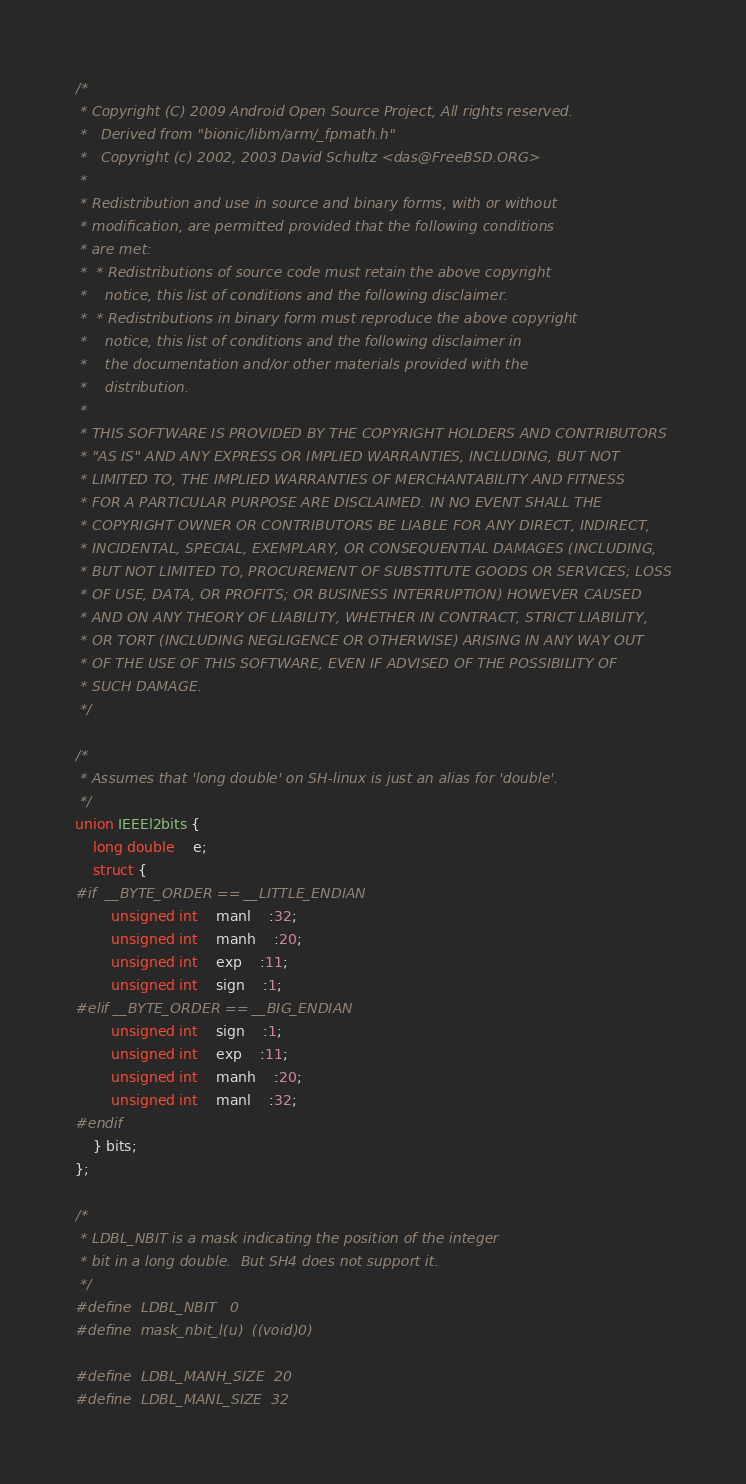Convert code to text. <code><loc_0><loc_0><loc_500><loc_500><_C_>/*
 * Copyright (C) 2009 Android Open Source Project, All rights reserved.
 *   Derived from "bionic/libm/arm/_fpmath.h"
 *   Copyright (c) 2002, 2003 David Schultz <das@FreeBSD.ORG>
 *
 * Redistribution and use in source and binary forms, with or without
 * modification, are permitted provided that the following conditions
 * are met:
 *  * Redistributions of source code must retain the above copyright
 *    notice, this list of conditions and the following disclaimer.
 *  * Redistributions in binary form must reproduce the above copyright
 *    notice, this list of conditions and the following disclaimer in
 *    the documentation and/or other materials provided with the
 *    distribution.
 *
 * THIS SOFTWARE IS PROVIDED BY THE COPYRIGHT HOLDERS AND CONTRIBUTORS
 * "AS IS" AND ANY EXPRESS OR IMPLIED WARRANTIES, INCLUDING, BUT NOT
 * LIMITED TO, THE IMPLIED WARRANTIES OF MERCHANTABILITY AND FITNESS
 * FOR A PARTICULAR PURPOSE ARE DISCLAIMED. IN NO EVENT SHALL THE
 * COPYRIGHT OWNER OR CONTRIBUTORS BE LIABLE FOR ANY DIRECT, INDIRECT,
 * INCIDENTAL, SPECIAL, EXEMPLARY, OR CONSEQUENTIAL DAMAGES (INCLUDING,
 * BUT NOT LIMITED TO, PROCUREMENT OF SUBSTITUTE GOODS OR SERVICES; LOSS
 * OF USE, DATA, OR PROFITS; OR BUSINESS INTERRUPTION) HOWEVER CAUSED
 * AND ON ANY THEORY OF LIABILITY, WHETHER IN CONTRACT, STRICT LIABILITY,
 * OR TORT (INCLUDING NEGLIGENCE OR OTHERWISE) ARISING IN ANY WAY OUT
 * OF THE USE OF THIS SOFTWARE, EVEN IF ADVISED OF THE POSSIBILITY OF
 * SUCH DAMAGE.
 */

/*
 * Assumes that 'long double' on SH-linux is just an alias for 'double'.
 */
union IEEEl2bits {
	long double	e;
	struct {
#if  __BYTE_ORDER == __LITTLE_ENDIAN
		unsigned int	manl	:32;
		unsigned int	manh	:20;
		unsigned int	exp	:11;
		unsigned int	sign	:1;
#elif __BYTE_ORDER == __BIG_ENDIAN
		unsigned int	sign	:1;
		unsigned int	exp	:11;
		unsigned int	manh	:20;
		unsigned int	manl	:32;
#endif
	} bits;
};

/*
 * LDBL_NBIT is a mask indicating the position of the integer
 * bit in a long double.  But SH4 does not support it.
 */
#define	LDBL_NBIT	0
#define	mask_nbit_l(u)	((void)0)

#define	LDBL_MANH_SIZE	20
#define	LDBL_MANL_SIZE	32
</code> 